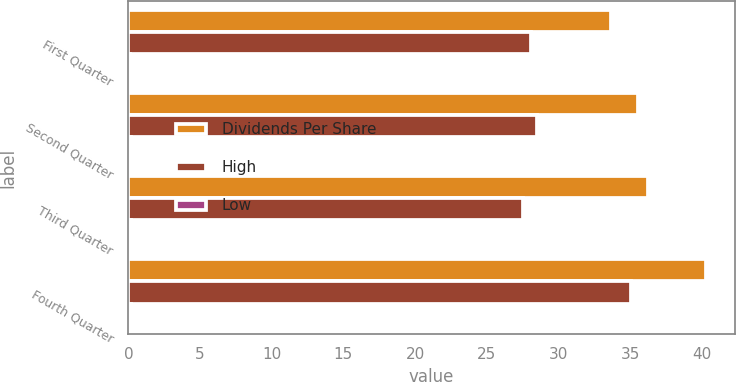Convert chart. <chart><loc_0><loc_0><loc_500><loc_500><stacked_bar_chart><ecel><fcel>First Quarter<fcel>Second Quarter<fcel>Third Quarter<fcel>Fourth Quarter<nl><fcel>Dividends Per Share<fcel>33.66<fcel>35.54<fcel>36.24<fcel>40.29<nl><fcel>High<fcel>28.09<fcel>28.49<fcel>27.54<fcel>35.08<nl><fcel>Low<fcel>0.12<fcel>0.15<fcel>0.15<fcel>0.15<nl></chart> 